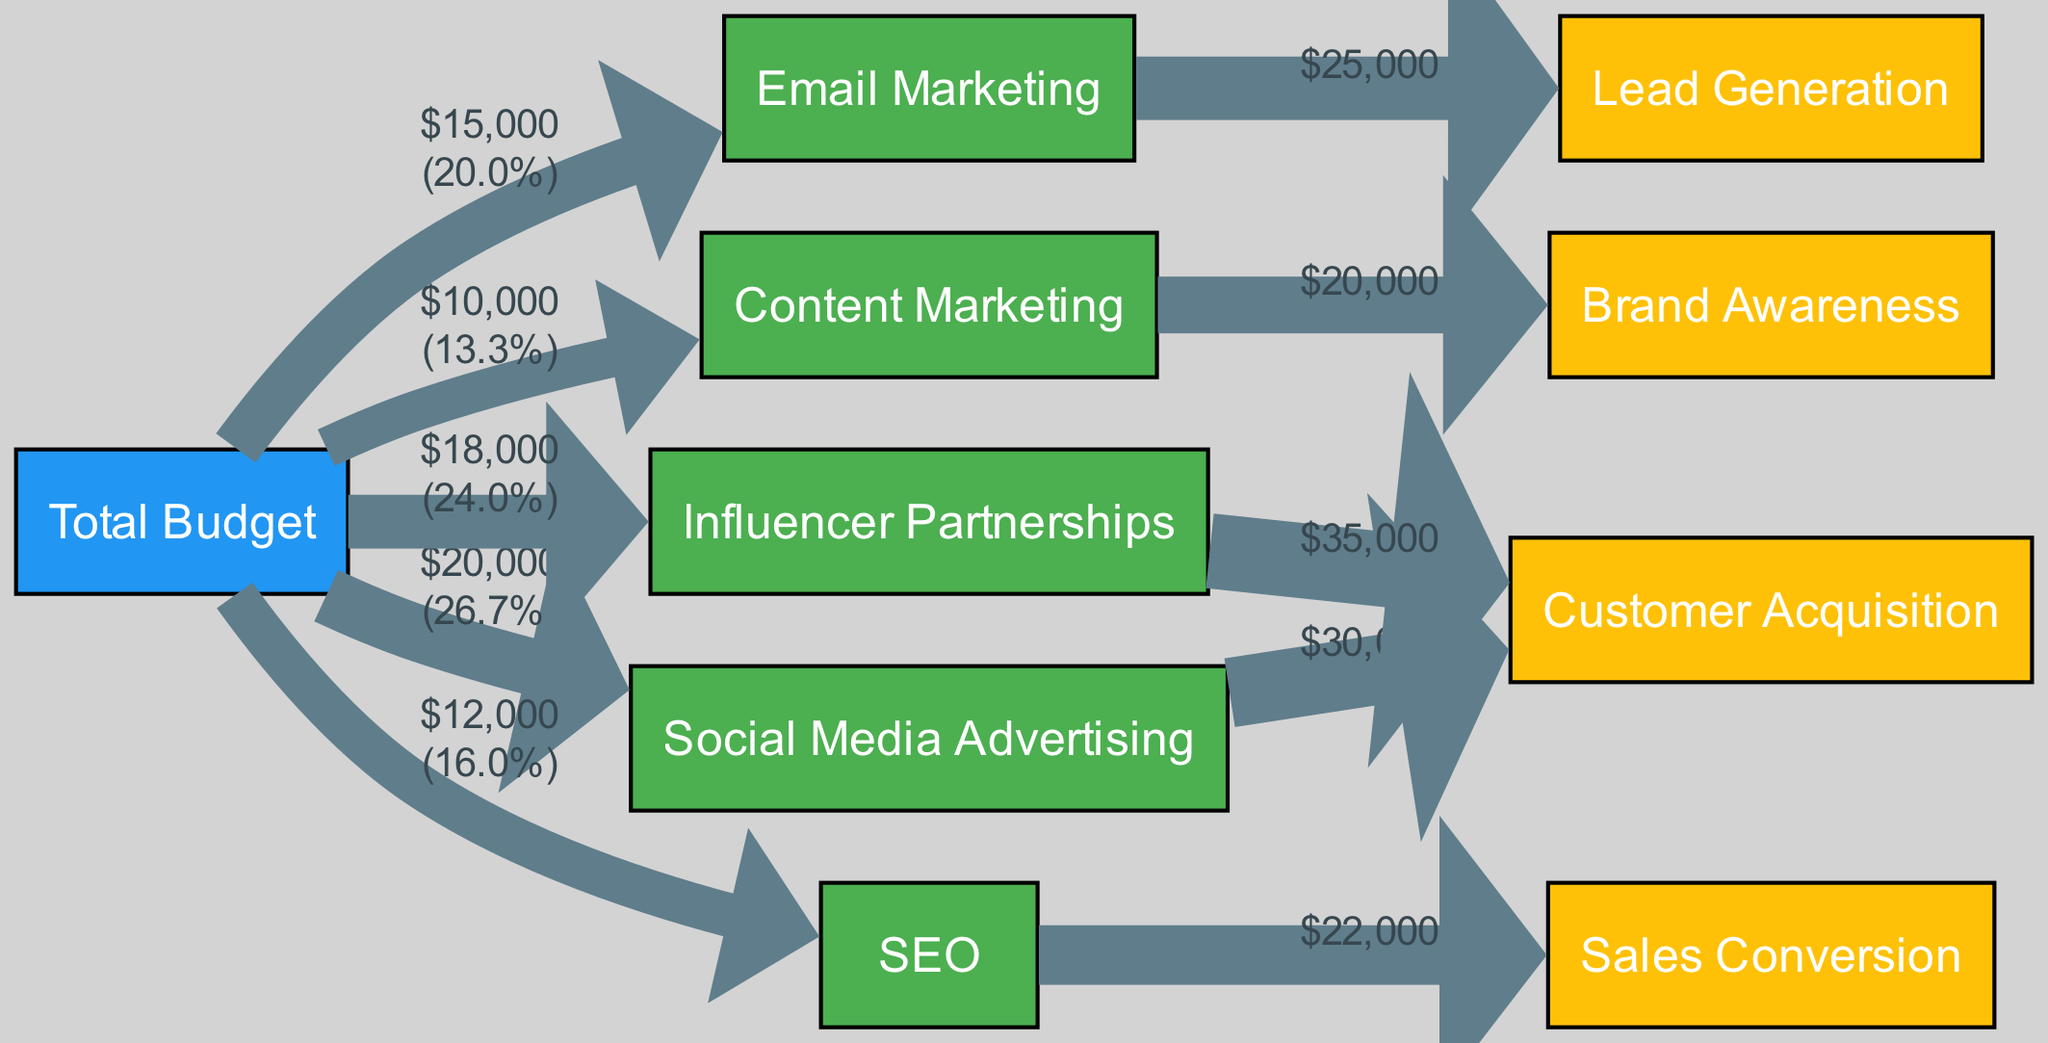What is the total budget allocated for marketing campaigns in Q2 2023? The diagram indicates that the total budget is shown as the starting node from which all channel allocations originate. By totaling the values assigned to each marketing channel from the Total Budget node, we arrive at $100,000.
Answer: $100,000 Which marketing channel received the highest budget allocation? By examining the links originating from the Total Budget node, it's clear that the largest individual allocation is $20,000 for Social Media Advertising, which is greater than all other channels.
Answer: Social Media Advertising What percentage of the total budget was allocated to Email Marketing? To find the percentage allocated to Email Marketing, we divide its budget of $15,000 by the total budget of $100,000 and multiply by 100, resulting in a percentage of 15%.
Answer: 15% How much return on investment did Influencer Partnerships achieve for Customer Acquisition? The link from Influencer Partnerships to Customer Acquisition shows a value of $35,000, indicating the return generated from that specific channel for this ROI category.
Answer: $35,000 Which ROI category received the least financial return? By evaluating the return values flowing out of the various marketing channels, the smallest return appears to be for Brand Awareness from Content Marketing, amounting to $20,000.
Answer: Brand Awareness How many total channels are displayed in the diagram? Counting all nodes classified as Channels gives us a total of five distinct channels used for marketing in the campaign.
Answer: 5 What is the total return generated from SEO efforts specifically for Sales Conversion? The diagram shows a direct link from SEO to Sales Conversion with a value of $22,000, which indicates the total revenue generated through this channel based on sales.
Answer: $22,000 Which channel shows the highest total return on investment? By comparing the total returns for each channel, Influencer Partnerships yields the highest total through Customer Acquisition, providing a return of $35,000.
Answer: Influencer Partnerships What is the relationship between Content Marketing and Brand Awareness? The flow link from Content Marketing leads directly to Brand Awareness, demonstrating that the campaign's expenditure in Content Marketing is specifically aimed at enhancing brand awareness with a return value of $20,000.
Answer: Positive relationship 